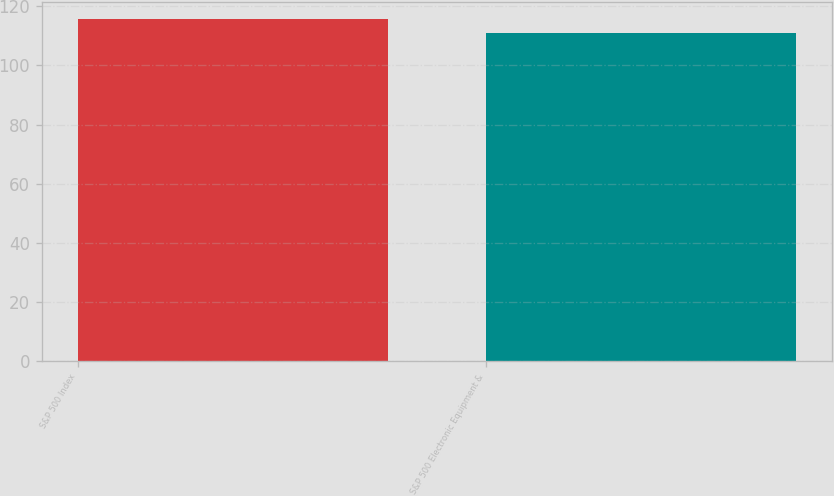<chart> <loc_0><loc_0><loc_500><loc_500><bar_chart><fcel>S&P 500 Index<fcel>S&P 500 Electronic Equipment &<nl><fcel>115.79<fcel>110.96<nl></chart> 